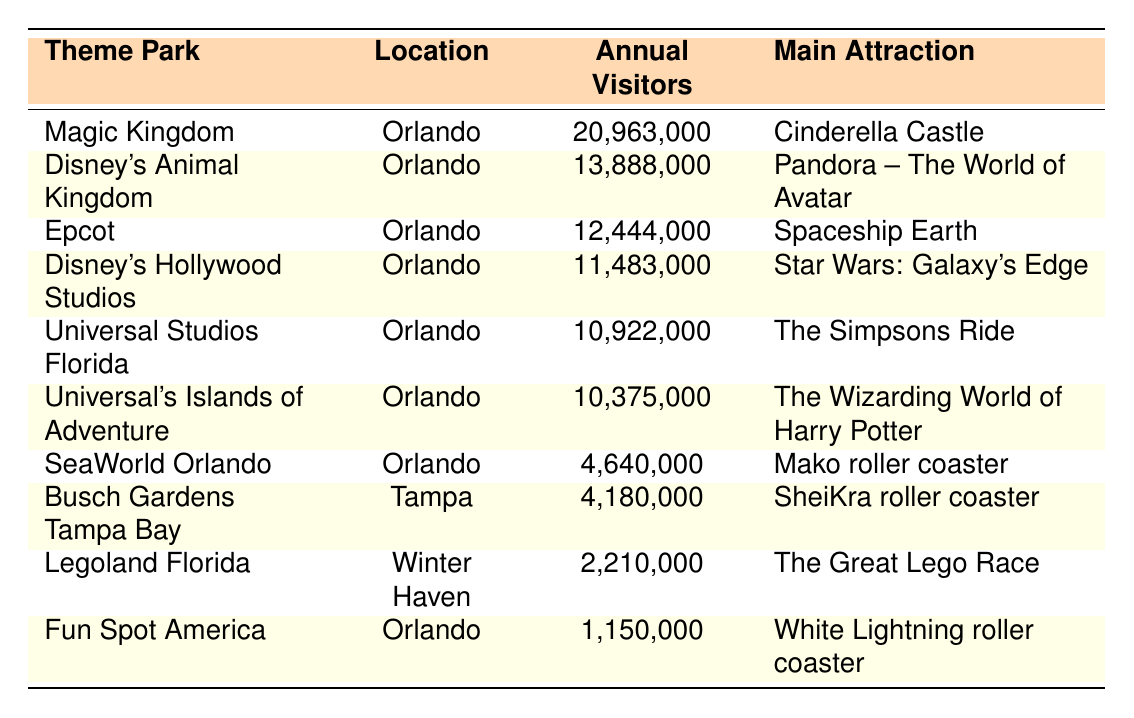What is the main attraction of the Magic Kingdom? The table shows that the main attraction of the Magic Kingdom is "Cinderella Castle."
Answer: Cinderella Castle How many annual visitors did SeaWorld Orlando have in 2019? From the table, SeaWorld Orlando had 4,640,000 annual visitors in 2019.
Answer: 4,640,000 Which theme park had the highest number of annual visitors? By comparing the visitor counts in the table, Magic Kingdom has the highest number of annual visitors at 20,963,000.
Answer: Magic Kingdom What is the difference in annual visitors between Epcot and Disney's Hollywood Studios? The annual visitors for Epcot are 12,444,000 and for Disney's Hollywood Studios are 11,483,000. The difference is 12,444,000 - 11,483,000 = 961,000.
Answer: 961,000 What is the average number of annual visitors for the top five theme parks? Summing the visitors for the top five parks: 20,963,000 + 13,888,000 + 12,444,000 + 11,483,000 + 10,922,000 = 79,700,000. Dividing by 5 gives an average of 15,940,000.
Answer: 15,940,000 Is Legoland Florida among the top three most visited theme parks? Legoland Florida has 2,210,000 visitors, and by checking the table, it's ranked much lower than the top three parks.
Answer: No Which location has the most theme parks listed in the table? The table indicates that Orlando has the most theme parks listed: Magic Kingdom, Disney's Animal Kingdom, Epcot, Disney's Hollywood Studios, Universal Studios Florida, Universal's Islands of Adventure, and SeaWorld Orlando. Counting these gives 7 parks.
Answer: Orlando What is the total number of annual visitors for all the theme parks listed? Adding all annual visitors: 20,963,000 + 13,888,000 + 12,444,000 + 11,483,000 + 10,922,000 + 10,375,000 + 4,640,000 + 4,180,000 + 2,210,000 + 1,150,000 gives a total of  92,455,000.
Answer: 92,455,000 Which park saw the least number of annual visitors? The park with the least annual visitors is Fun Spot America with 1,150,000 visitors according to the table.
Answer: Fun Spot America How many more visitors did Universal Studios Florida have compared to SeaWorld Orlando? Universal Studios Florida had 10,922,000 visitors while SeaWorld Orlando had 4,640,000 visitors, so the difference is 10,922,000 - 4,640,000 = 6,282,000.
Answer: 6,282,000 Can we say that all theme parks listed are located in Orlando? By checking the table, we find that not all parks are in Orlando; for example, Busch Gardens is in Tampa and Legoland Florida is in Winter Haven.
Answer: No 